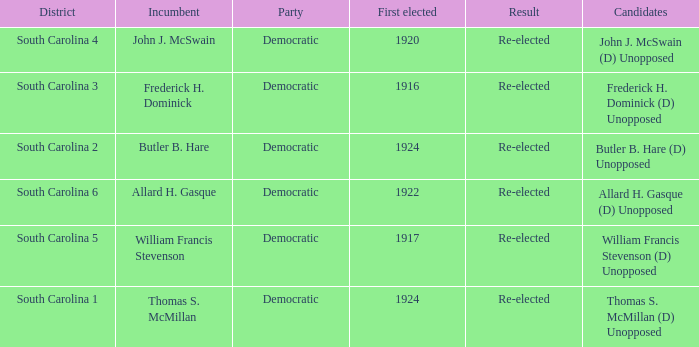Name the candidate for south carolina 1? Thomas S. McMillan (D) Unopposed. 